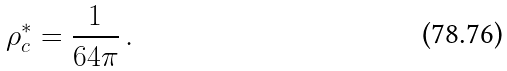Convert formula to latex. <formula><loc_0><loc_0><loc_500><loc_500>\rho _ { c } ^ { * } = \frac { 1 } { 6 4 \pi } \, .</formula> 